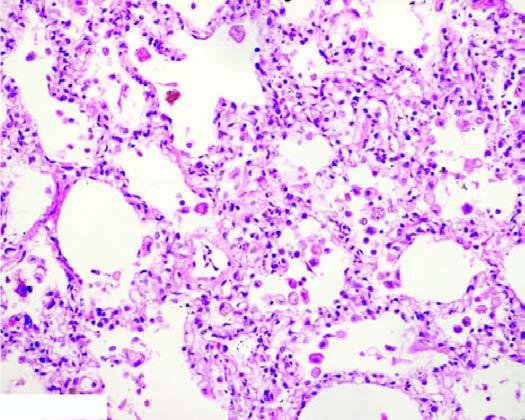do line of demarcation between gangrenous segment and the viable bowel contain heart failure cells alveolar macrophages containing haemosiderin pigment?
Answer the question using a single word or phrase. No 